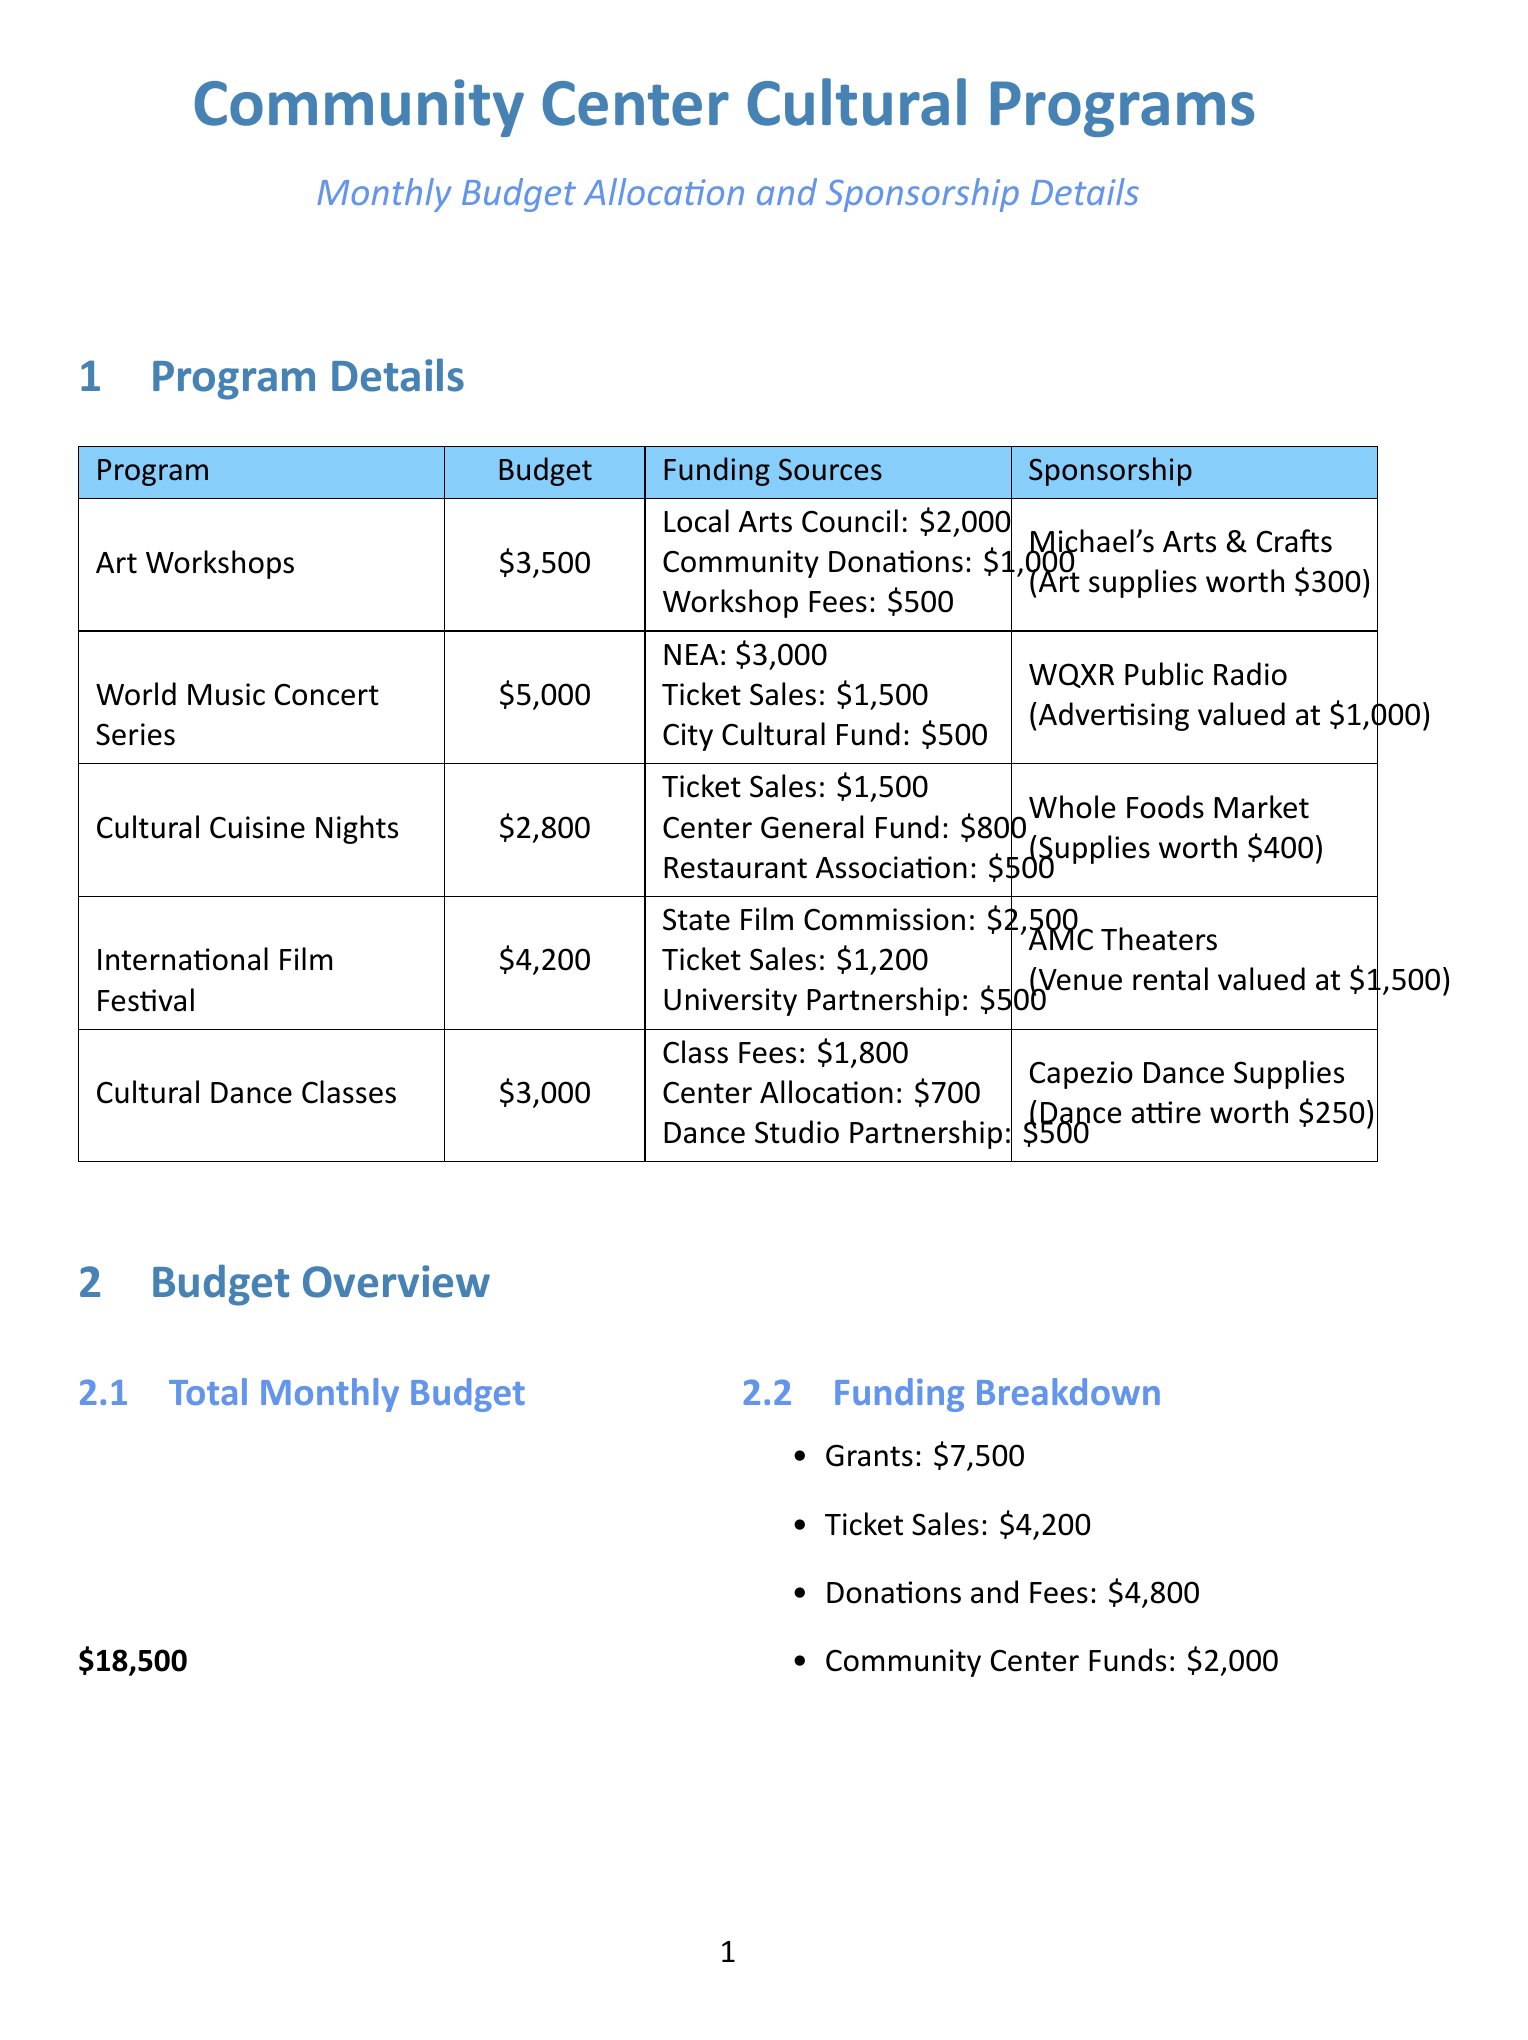What is the monthly budget for Art Workshops? The budget for Art Workshops is provided in the document under the 'Monthly Budget' column.
Answer: 3500 Who is the sponsor for the International Film Festival? The sponsor for the International Film Festival is listed in the sponsorship section of the document.
Answer: AMC Theaters What is the total monthly budget for all cultural programs? The total monthly budget is found in the Budget Overview section and represents the sum of all program budgets.
Answer: 18500 How much funding does the National Endowment for the Arts provide for the World Music Concert Series? The amount from the National Endowment for the Arts is given in the funding sources for the World Music Concert Series.
Answer: 3000 Which cultural program receives sponsorship from Whole Foods Market? The program associated with Whole Foods Market is identified in the sponsorship details of the document.
Answer: Cultural Cuisine Nights What is the total amount allocated to grants? The total allocated to grants is listed in the Funding Breakdown section of the document.
Answer: 7500 What kind of contribution does Capezio Dance Supplies provide? The type of sponsorship contribution from Capezio Dance Supplies is specified in their sponsorship details.
Answer: Dance shoes and attire worth 250 Which program has the lowest monthly budget? The lowest budget program can be determined by comparing budgets listed in the Program Details section.
Answer: Cultural Cuisine Nights How many top sponsors are mentioned in the document? The number of top sponsors is indicated in the Top Sponsors section, which lists them all.
Answer: 5 